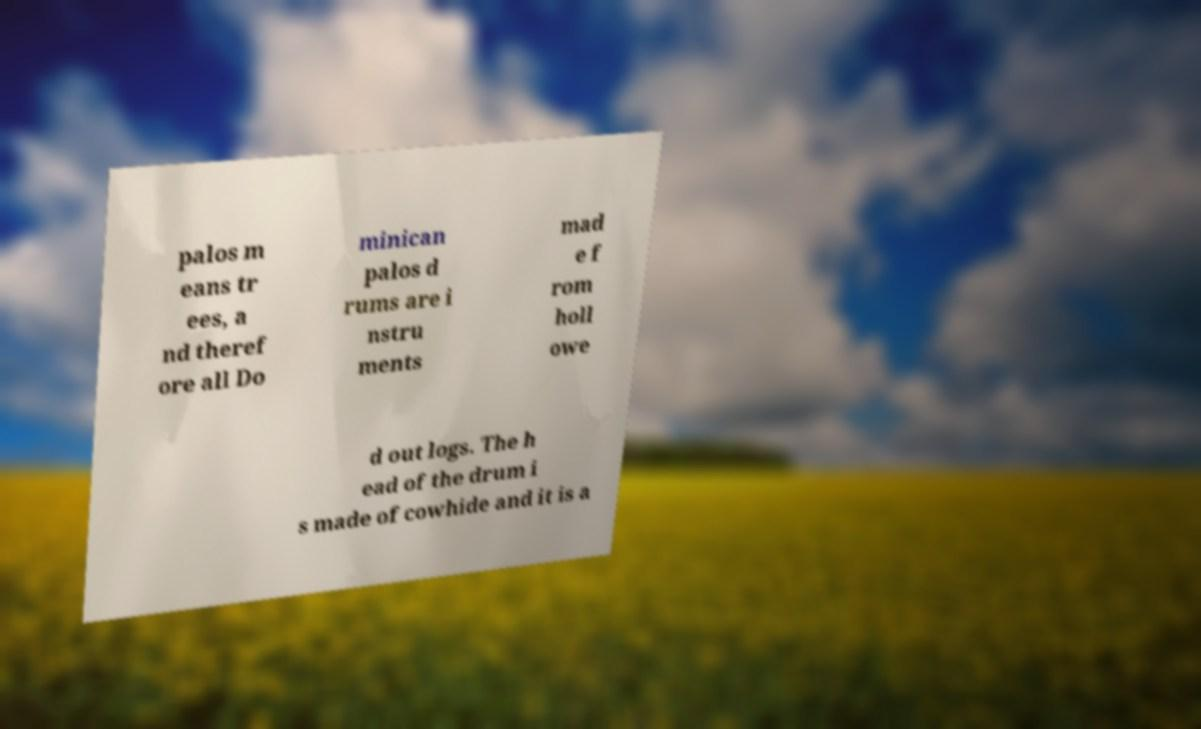Could you assist in decoding the text presented in this image and type it out clearly? palos m eans tr ees, a nd theref ore all Do minican palos d rums are i nstru ments mad e f rom holl owe d out logs. The h ead of the drum i s made of cowhide and it is a 